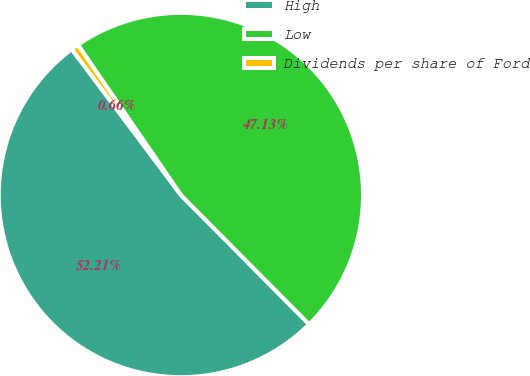Convert chart to OTSL. <chart><loc_0><loc_0><loc_500><loc_500><pie_chart><fcel>High<fcel>Low<fcel>Dividends per share of Ford<nl><fcel>52.21%<fcel>47.13%<fcel>0.66%<nl></chart> 